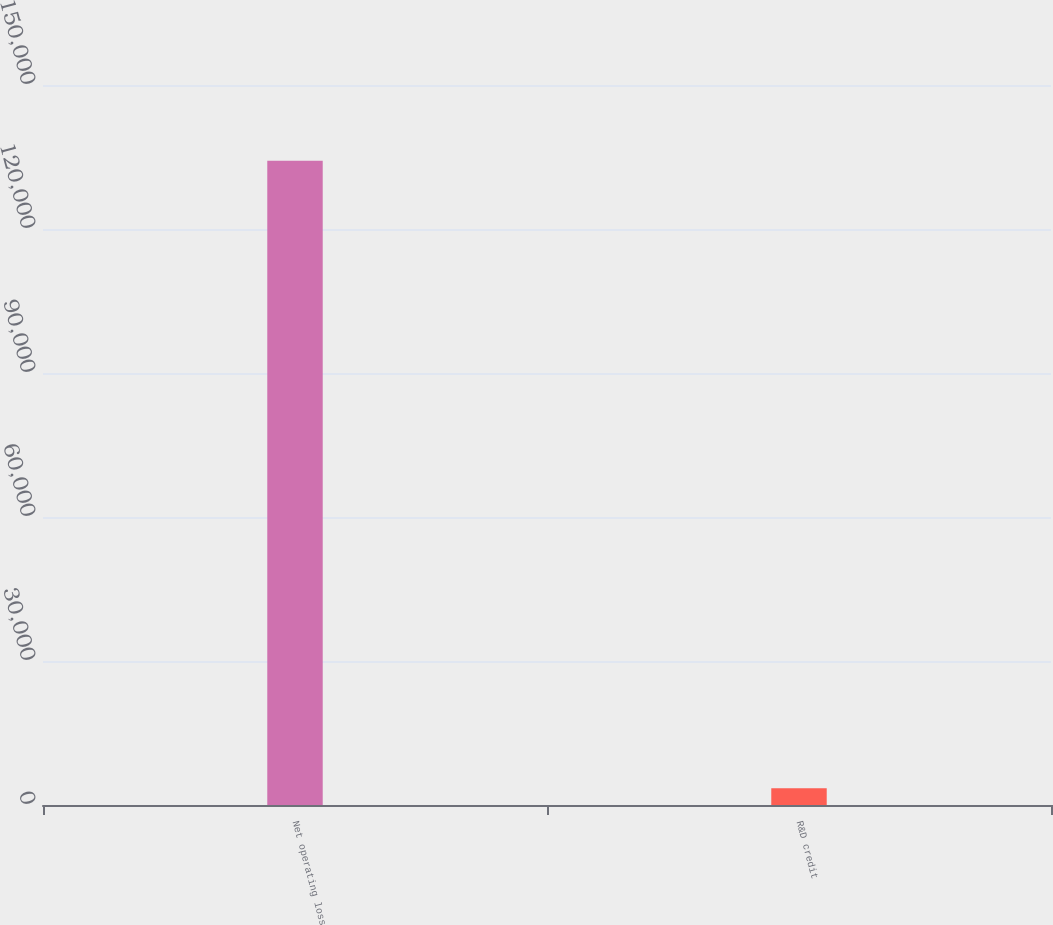<chart> <loc_0><loc_0><loc_500><loc_500><bar_chart><fcel>Net operating loss<fcel>R&D credit<nl><fcel>134196<fcel>3502<nl></chart> 